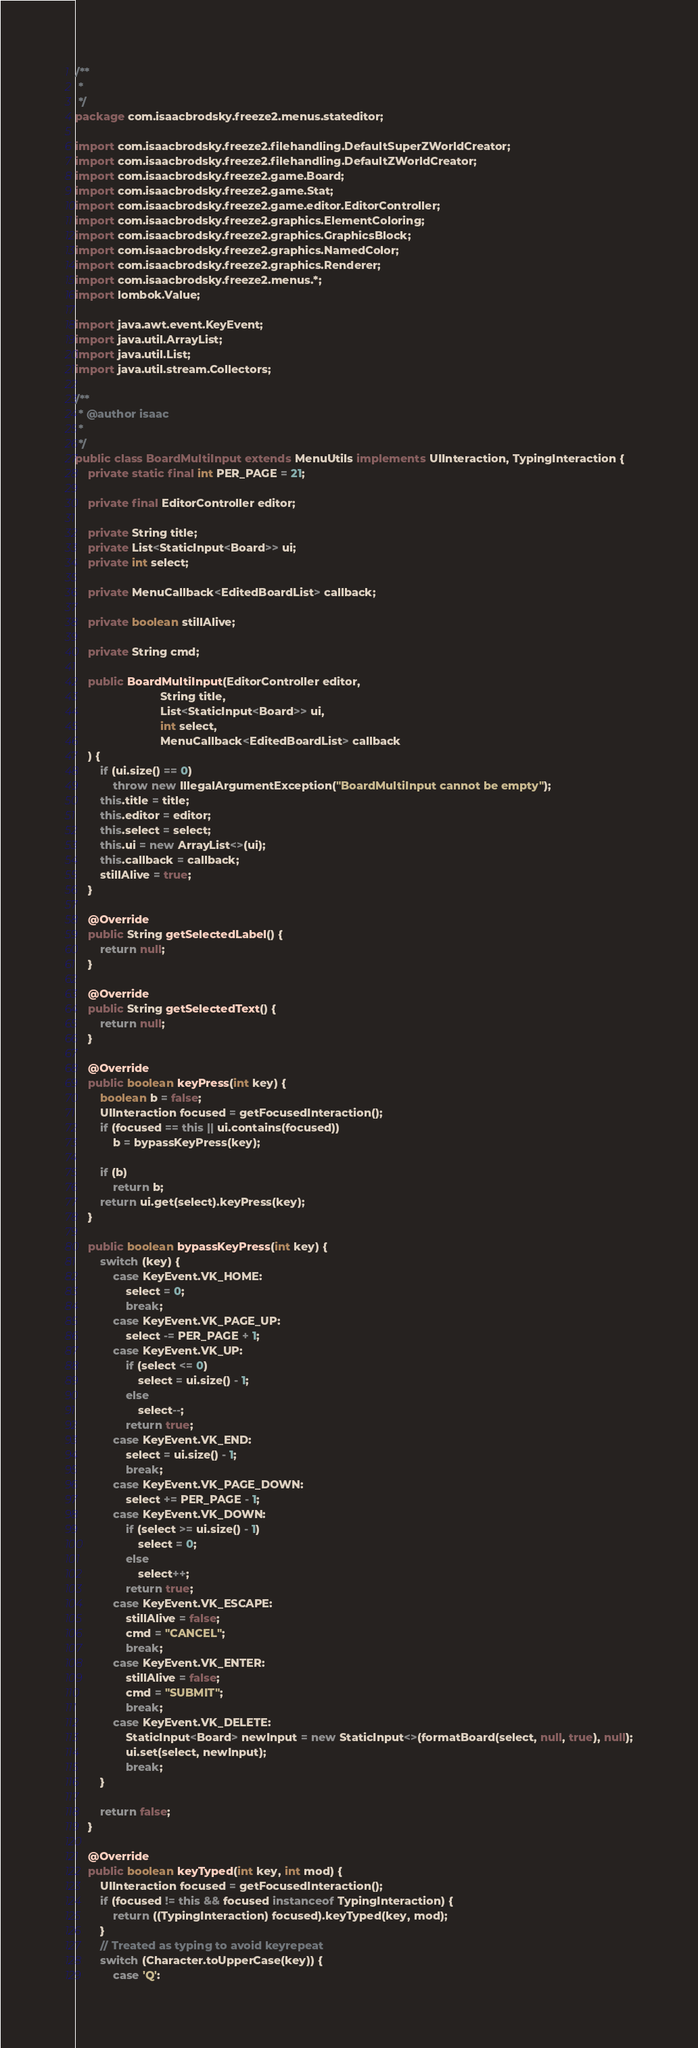Convert code to text. <code><loc_0><loc_0><loc_500><loc_500><_Java_>/**
 * 
 */
package com.isaacbrodsky.freeze2.menus.stateditor;

import com.isaacbrodsky.freeze2.filehandling.DefaultSuperZWorldCreator;
import com.isaacbrodsky.freeze2.filehandling.DefaultZWorldCreator;
import com.isaacbrodsky.freeze2.game.Board;
import com.isaacbrodsky.freeze2.game.Stat;
import com.isaacbrodsky.freeze2.game.editor.EditorController;
import com.isaacbrodsky.freeze2.graphics.ElementColoring;
import com.isaacbrodsky.freeze2.graphics.GraphicsBlock;
import com.isaacbrodsky.freeze2.graphics.NamedColor;
import com.isaacbrodsky.freeze2.graphics.Renderer;
import com.isaacbrodsky.freeze2.menus.*;
import lombok.Value;

import java.awt.event.KeyEvent;
import java.util.ArrayList;
import java.util.List;
import java.util.stream.Collectors;

/**
 * @author isaac
 * 
 */
public class BoardMultiInput extends MenuUtils implements UIInteraction, TypingInteraction {
	private static final int PER_PAGE = 21;

	private final EditorController editor;

	private String title;
	private List<StaticInput<Board>> ui;
	private int select;

	private MenuCallback<EditedBoardList> callback;

	private boolean stillAlive;

	private String cmd;

	public BoardMultiInput(EditorController editor,
                           String title,
                           List<StaticInput<Board>> ui,
                           int select,
						   MenuCallback<EditedBoardList> callback
	) {
		if (ui.size() == 0)
			throw new IllegalArgumentException("BoardMultiInput cannot be empty");
		this.title = title;
		this.editor = editor;
		this.select = select;
		this.ui = new ArrayList<>(ui);
		this.callback = callback;
		stillAlive = true;
	}

	@Override
	public String getSelectedLabel() {
		return null;
	}

	@Override
	public String getSelectedText() {
		return null;
	}

	@Override
	public boolean keyPress(int key) {
		boolean b = false;
		UIInteraction focused = getFocusedInteraction();
		if (focused == this || ui.contains(focused))
			b = bypassKeyPress(key);

		if (b)
			return b;
		return ui.get(select).keyPress(key);
	}

	public boolean bypassKeyPress(int key) {
		switch (key) {
			case KeyEvent.VK_HOME:
				select = 0;
				break;
			case KeyEvent.VK_PAGE_UP:
				select -= PER_PAGE + 1;
			case KeyEvent.VK_UP:
				if (select <= 0)
					select = ui.size() - 1;
				else
					select--;
				return true;
			case KeyEvent.VK_END:
				select = ui.size() - 1;
				break;
			case KeyEvent.VK_PAGE_DOWN:
				select += PER_PAGE - 1;
			case KeyEvent.VK_DOWN:
				if (select >= ui.size() - 1)
					select = 0;
				else
					select++;
				return true;
			case KeyEvent.VK_ESCAPE:
				stillAlive = false;
				cmd = "CANCEL";
				break;
			case KeyEvent.VK_ENTER:
				stillAlive = false;
				cmd = "SUBMIT";
				break;
			case KeyEvent.VK_DELETE:
				StaticInput<Board> newInput = new StaticInput<>(formatBoard(select, null, true), null);
				ui.set(select, newInput);
				break;
		}

		return false;
	}

	@Override
	public boolean keyTyped(int key, int mod) {
		UIInteraction focused = getFocusedInteraction();
		if (focused != this && focused instanceof TypingInteraction) {
			return ((TypingInteraction) focused).keyTyped(key, mod);
		}
		// Treated as typing to avoid keyrepeat
		switch (Character.toUpperCase(key)) {
			case 'Q':</code> 